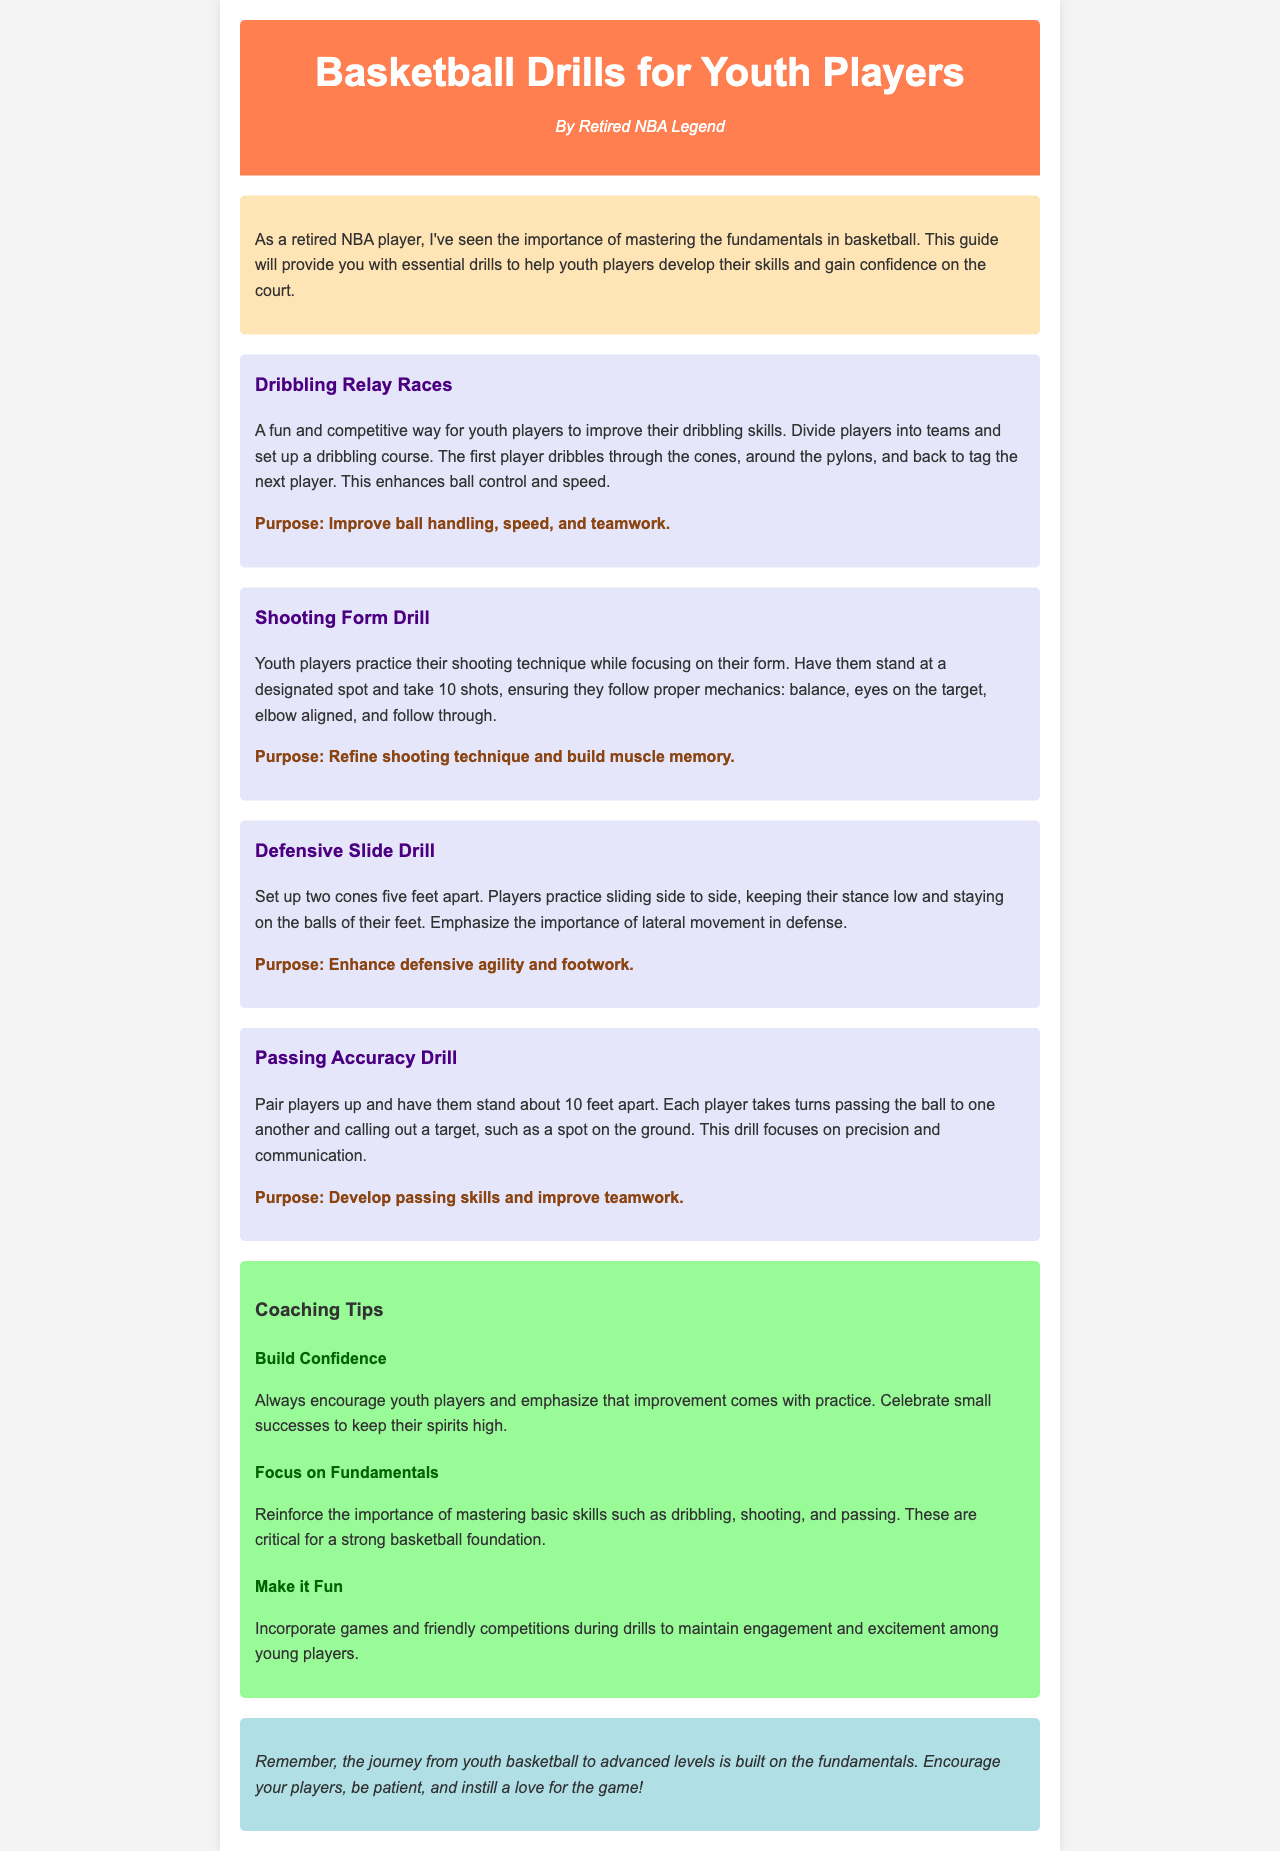what is the title of the guide? The title of the guide is presented prominently at the top of the document, summarizing its purpose.
Answer: Basketball Drills for Youth Players who is the author of the newsletter? The author is mentioned in the header section, indicating their background in the sport.
Answer: Retired NBA Legend what is the purpose of the Shooting Form Drill? The purpose is specifically stated after each drill, highlighting its focus.
Answer: Refine shooting technique and build muscle memory how many drills are listed in the document? The number of drills can be counted from the drills section of the document.
Answer: Four what is one key emphasis in the Defensive Slide Drill? The key emphasis is derived from the description of this particular drill in the document.
Answer: Lateral movement in defense which drill focuses on teamwork? The focus on teamwork is explicitly mentioned in the context of the relevant drill.
Answer: Passing Accuracy Drill what is one of the coaching tips mentioned? The coaching tips are listed with specific headlines, emphasizing different strategies.
Answer: Build Confidence what background does the author have? The author's background is briefly mentioned, establishing credibility in basketball.
Answer: NBA player what color is the background of the introduction section? The color of the background is described in the CSS styling for that section.
Answer: Light yellow 